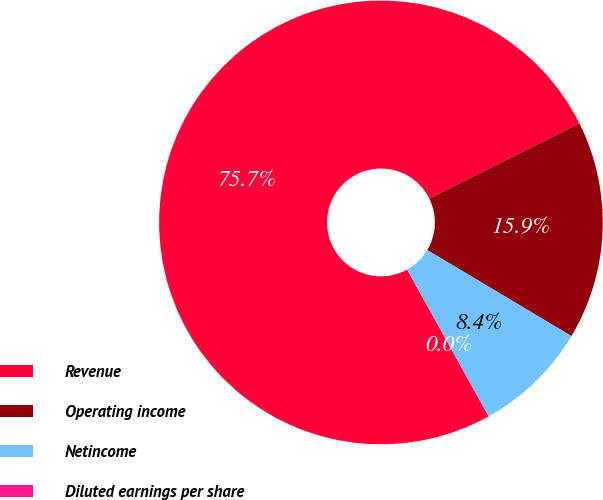Convert chart. <chart><loc_0><loc_0><loc_500><loc_500><pie_chart><fcel>Revenue<fcel>Operating income<fcel>Netincome<fcel>Diluted earnings per share<nl><fcel>75.69%<fcel>15.94%<fcel>8.37%<fcel>0.0%<nl></chart> 